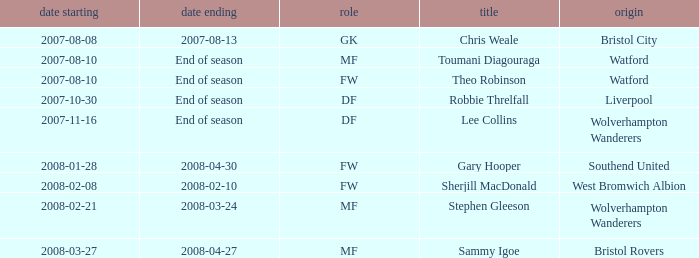Where was the player from who had the position of DF, who started 2007-10-30? Liverpool. 